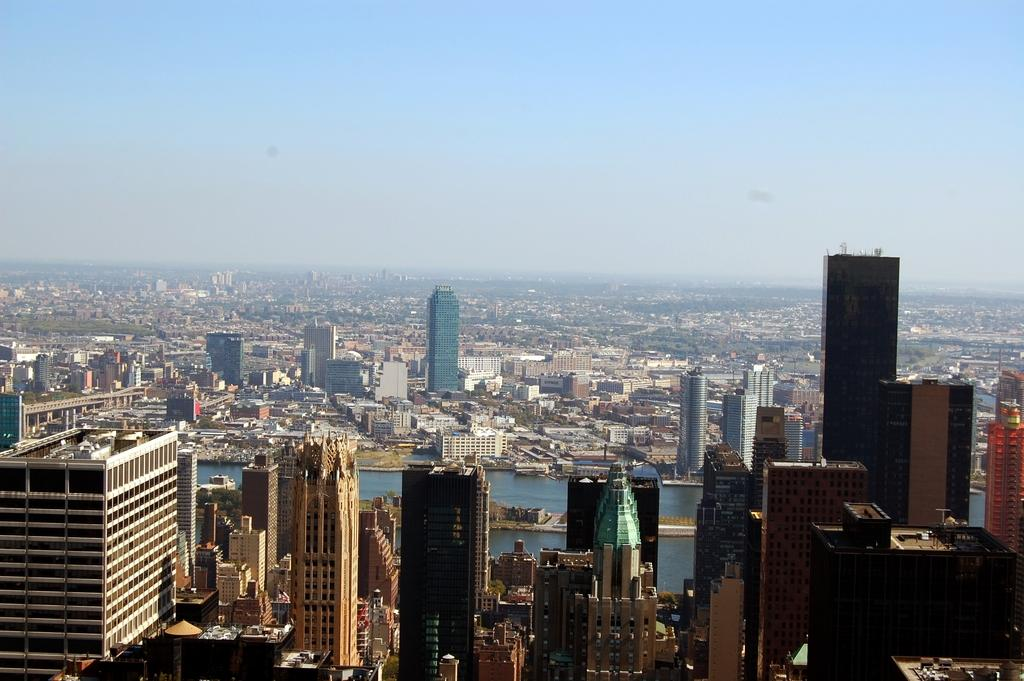What type of structures are visible in the image? There are huge buildings in the image. What natural feature is present between the buildings? There is a river between the buildings. What is the condition of the sky in the image? The sky is clear in the image. What type of suit is the lawyer wearing in the image? There is no lawyer or suit present in the image. What type of paste is being used to create the buildings in the image? The buildings in the image are not made of paste; they are real structures. 